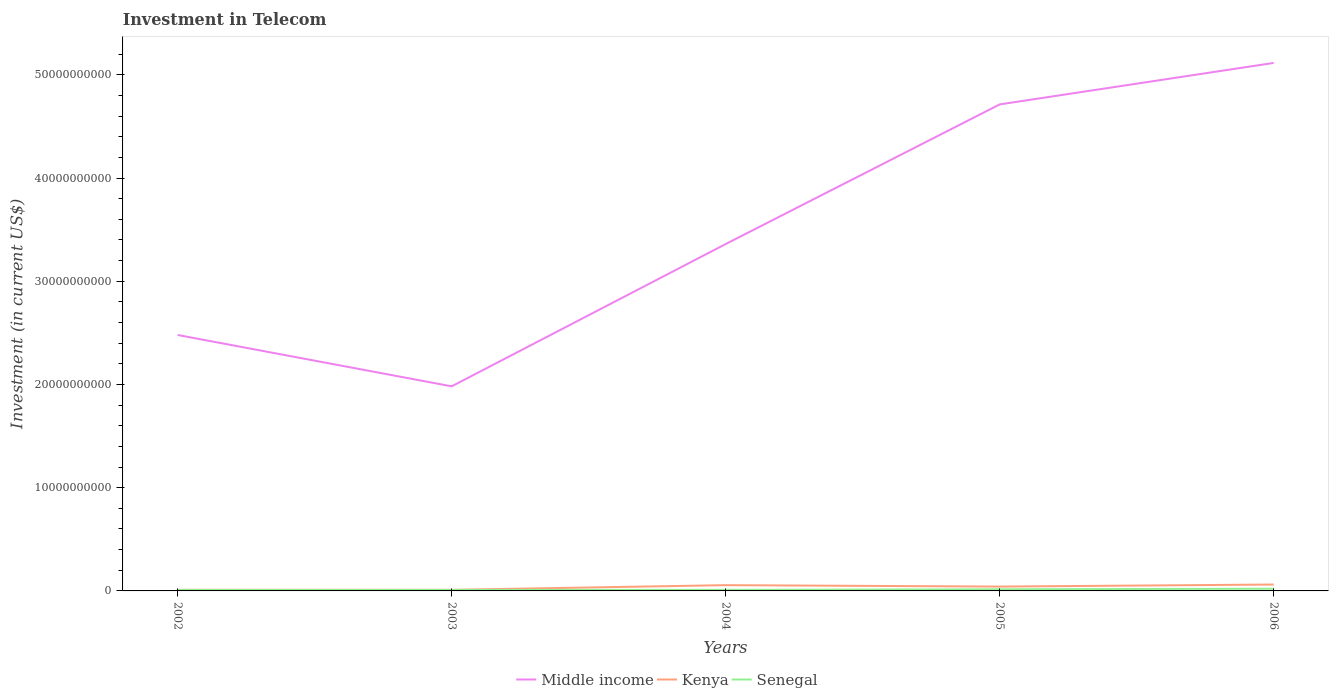Does the line corresponding to Middle income intersect with the line corresponding to Kenya?
Provide a short and direct response. No. Is the number of lines equal to the number of legend labels?
Offer a very short reply. Yes. Across all years, what is the maximum amount invested in telecom in Senegal?
Provide a short and direct response. 9.40e+07. In which year was the amount invested in telecom in Kenya maximum?
Make the answer very short. 2002. What is the total amount invested in telecom in Middle income in the graph?
Provide a short and direct response. -3.13e+1. What is the difference between the highest and the second highest amount invested in telecom in Middle income?
Your answer should be very brief. 3.13e+1. Is the amount invested in telecom in Middle income strictly greater than the amount invested in telecom in Senegal over the years?
Ensure brevity in your answer.  No. How many years are there in the graph?
Provide a succinct answer. 5. Does the graph contain any zero values?
Offer a very short reply. No. Does the graph contain grids?
Your response must be concise. No. Where does the legend appear in the graph?
Ensure brevity in your answer.  Bottom center. What is the title of the graph?
Make the answer very short. Investment in Telecom. Does "Brazil" appear as one of the legend labels in the graph?
Give a very brief answer. No. What is the label or title of the X-axis?
Keep it short and to the point. Years. What is the label or title of the Y-axis?
Make the answer very short. Investment (in current US$). What is the Investment (in current US$) in Middle income in 2002?
Give a very brief answer. 2.48e+1. What is the Investment (in current US$) of Kenya in 2002?
Ensure brevity in your answer.  1.08e+08. What is the Investment (in current US$) in Senegal in 2002?
Your answer should be compact. 9.40e+07. What is the Investment (in current US$) of Middle income in 2003?
Provide a succinct answer. 1.98e+1. What is the Investment (in current US$) of Kenya in 2003?
Offer a terse response. 1.08e+08. What is the Investment (in current US$) of Senegal in 2003?
Provide a succinct answer. 9.53e+07. What is the Investment (in current US$) in Middle income in 2004?
Provide a short and direct response. 3.36e+1. What is the Investment (in current US$) of Kenya in 2004?
Keep it short and to the point. 5.59e+08. What is the Investment (in current US$) in Senegal in 2004?
Your answer should be very brief. 1.04e+08. What is the Investment (in current US$) of Middle income in 2005?
Make the answer very short. 4.71e+1. What is the Investment (in current US$) of Kenya in 2005?
Keep it short and to the point. 4.21e+08. What is the Investment (in current US$) of Senegal in 2005?
Provide a short and direct response. 1.57e+08. What is the Investment (in current US$) in Middle income in 2006?
Provide a short and direct response. 5.12e+1. What is the Investment (in current US$) of Kenya in 2006?
Offer a very short reply. 6.19e+08. What is the Investment (in current US$) in Senegal in 2006?
Your answer should be compact. 2.12e+08. Across all years, what is the maximum Investment (in current US$) in Middle income?
Give a very brief answer. 5.12e+1. Across all years, what is the maximum Investment (in current US$) in Kenya?
Ensure brevity in your answer.  6.19e+08. Across all years, what is the maximum Investment (in current US$) of Senegal?
Give a very brief answer. 2.12e+08. Across all years, what is the minimum Investment (in current US$) of Middle income?
Make the answer very short. 1.98e+1. Across all years, what is the minimum Investment (in current US$) of Kenya?
Your answer should be very brief. 1.08e+08. Across all years, what is the minimum Investment (in current US$) in Senegal?
Make the answer very short. 9.40e+07. What is the total Investment (in current US$) of Middle income in the graph?
Make the answer very short. 1.77e+11. What is the total Investment (in current US$) in Kenya in the graph?
Your answer should be compact. 1.82e+09. What is the total Investment (in current US$) in Senegal in the graph?
Your response must be concise. 6.62e+08. What is the difference between the Investment (in current US$) of Middle income in 2002 and that in 2003?
Your answer should be very brief. 4.97e+09. What is the difference between the Investment (in current US$) in Kenya in 2002 and that in 2003?
Provide a succinct answer. 0. What is the difference between the Investment (in current US$) of Senegal in 2002 and that in 2003?
Offer a terse response. -1.30e+06. What is the difference between the Investment (in current US$) of Middle income in 2002 and that in 2004?
Offer a terse response. -8.81e+09. What is the difference between the Investment (in current US$) in Kenya in 2002 and that in 2004?
Your response must be concise. -4.51e+08. What is the difference between the Investment (in current US$) of Senegal in 2002 and that in 2004?
Your answer should be compact. -1.00e+07. What is the difference between the Investment (in current US$) of Middle income in 2002 and that in 2005?
Offer a very short reply. -2.23e+1. What is the difference between the Investment (in current US$) of Kenya in 2002 and that in 2005?
Your answer should be compact. -3.13e+08. What is the difference between the Investment (in current US$) in Senegal in 2002 and that in 2005?
Offer a terse response. -6.30e+07. What is the difference between the Investment (in current US$) in Middle income in 2002 and that in 2006?
Your response must be concise. -2.64e+1. What is the difference between the Investment (in current US$) of Kenya in 2002 and that in 2006?
Provide a succinct answer. -5.11e+08. What is the difference between the Investment (in current US$) of Senegal in 2002 and that in 2006?
Keep it short and to the point. -1.18e+08. What is the difference between the Investment (in current US$) in Middle income in 2003 and that in 2004?
Make the answer very short. -1.38e+1. What is the difference between the Investment (in current US$) of Kenya in 2003 and that in 2004?
Your answer should be compact. -4.51e+08. What is the difference between the Investment (in current US$) of Senegal in 2003 and that in 2004?
Provide a short and direct response. -8.70e+06. What is the difference between the Investment (in current US$) in Middle income in 2003 and that in 2005?
Your answer should be very brief. -2.73e+1. What is the difference between the Investment (in current US$) of Kenya in 2003 and that in 2005?
Offer a terse response. -3.13e+08. What is the difference between the Investment (in current US$) of Senegal in 2003 and that in 2005?
Offer a very short reply. -6.17e+07. What is the difference between the Investment (in current US$) of Middle income in 2003 and that in 2006?
Your answer should be very brief. -3.13e+1. What is the difference between the Investment (in current US$) of Kenya in 2003 and that in 2006?
Keep it short and to the point. -5.11e+08. What is the difference between the Investment (in current US$) in Senegal in 2003 and that in 2006?
Offer a very short reply. -1.17e+08. What is the difference between the Investment (in current US$) in Middle income in 2004 and that in 2005?
Provide a short and direct response. -1.35e+1. What is the difference between the Investment (in current US$) in Kenya in 2004 and that in 2005?
Ensure brevity in your answer.  1.38e+08. What is the difference between the Investment (in current US$) of Senegal in 2004 and that in 2005?
Offer a very short reply. -5.30e+07. What is the difference between the Investment (in current US$) in Middle income in 2004 and that in 2006?
Make the answer very short. -1.75e+1. What is the difference between the Investment (in current US$) of Kenya in 2004 and that in 2006?
Offer a terse response. -6.00e+07. What is the difference between the Investment (in current US$) of Senegal in 2004 and that in 2006?
Provide a short and direct response. -1.08e+08. What is the difference between the Investment (in current US$) in Middle income in 2005 and that in 2006?
Your answer should be very brief. -4.02e+09. What is the difference between the Investment (in current US$) of Kenya in 2005 and that in 2006?
Your answer should be very brief. -1.98e+08. What is the difference between the Investment (in current US$) of Senegal in 2005 and that in 2006?
Provide a succinct answer. -5.50e+07. What is the difference between the Investment (in current US$) of Middle income in 2002 and the Investment (in current US$) of Kenya in 2003?
Give a very brief answer. 2.47e+1. What is the difference between the Investment (in current US$) in Middle income in 2002 and the Investment (in current US$) in Senegal in 2003?
Make the answer very short. 2.47e+1. What is the difference between the Investment (in current US$) in Kenya in 2002 and the Investment (in current US$) in Senegal in 2003?
Make the answer very short. 1.27e+07. What is the difference between the Investment (in current US$) of Middle income in 2002 and the Investment (in current US$) of Kenya in 2004?
Your answer should be very brief. 2.42e+1. What is the difference between the Investment (in current US$) in Middle income in 2002 and the Investment (in current US$) in Senegal in 2004?
Provide a short and direct response. 2.47e+1. What is the difference between the Investment (in current US$) in Middle income in 2002 and the Investment (in current US$) in Kenya in 2005?
Provide a short and direct response. 2.44e+1. What is the difference between the Investment (in current US$) in Middle income in 2002 and the Investment (in current US$) in Senegal in 2005?
Your response must be concise. 2.46e+1. What is the difference between the Investment (in current US$) in Kenya in 2002 and the Investment (in current US$) in Senegal in 2005?
Your answer should be compact. -4.90e+07. What is the difference between the Investment (in current US$) of Middle income in 2002 and the Investment (in current US$) of Kenya in 2006?
Keep it short and to the point. 2.42e+1. What is the difference between the Investment (in current US$) of Middle income in 2002 and the Investment (in current US$) of Senegal in 2006?
Your answer should be very brief. 2.46e+1. What is the difference between the Investment (in current US$) of Kenya in 2002 and the Investment (in current US$) of Senegal in 2006?
Your answer should be very brief. -1.04e+08. What is the difference between the Investment (in current US$) in Middle income in 2003 and the Investment (in current US$) in Kenya in 2004?
Make the answer very short. 1.93e+1. What is the difference between the Investment (in current US$) in Middle income in 2003 and the Investment (in current US$) in Senegal in 2004?
Offer a terse response. 1.97e+1. What is the difference between the Investment (in current US$) of Kenya in 2003 and the Investment (in current US$) of Senegal in 2004?
Provide a short and direct response. 4.00e+06. What is the difference between the Investment (in current US$) in Middle income in 2003 and the Investment (in current US$) in Kenya in 2005?
Your answer should be compact. 1.94e+1. What is the difference between the Investment (in current US$) of Middle income in 2003 and the Investment (in current US$) of Senegal in 2005?
Provide a succinct answer. 1.97e+1. What is the difference between the Investment (in current US$) of Kenya in 2003 and the Investment (in current US$) of Senegal in 2005?
Keep it short and to the point. -4.90e+07. What is the difference between the Investment (in current US$) of Middle income in 2003 and the Investment (in current US$) of Kenya in 2006?
Ensure brevity in your answer.  1.92e+1. What is the difference between the Investment (in current US$) of Middle income in 2003 and the Investment (in current US$) of Senegal in 2006?
Offer a terse response. 1.96e+1. What is the difference between the Investment (in current US$) in Kenya in 2003 and the Investment (in current US$) in Senegal in 2006?
Ensure brevity in your answer.  -1.04e+08. What is the difference between the Investment (in current US$) of Middle income in 2004 and the Investment (in current US$) of Kenya in 2005?
Provide a short and direct response. 3.32e+1. What is the difference between the Investment (in current US$) of Middle income in 2004 and the Investment (in current US$) of Senegal in 2005?
Your answer should be very brief. 3.34e+1. What is the difference between the Investment (in current US$) in Kenya in 2004 and the Investment (in current US$) in Senegal in 2005?
Provide a succinct answer. 4.02e+08. What is the difference between the Investment (in current US$) of Middle income in 2004 and the Investment (in current US$) of Kenya in 2006?
Provide a short and direct response. 3.30e+1. What is the difference between the Investment (in current US$) of Middle income in 2004 and the Investment (in current US$) of Senegal in 2006?
Provide a short and direct response. 3.34e+1. What is the difference between the Investment (in current US$) in Kenya in 2004 and the Investment (in current US$) in Senegal in 2006?
Keep it short and to the point. 3.47e+08. What is the difference between the Investment (in current US$) in Middle income in 2005 and the Investment (in current US$) in Kenya in 2006?
Your response must be concise. 4.65e+1. What is the difference between the Investment (in current US$) in Middle income in 2005 and the Investment (in current US$) in Senegal in 2006?
Keep it short and to the point. 4.69e+1. What is the difference between the Investment (in current US$) in Kenya in 2005 and the Investment (in current US$) in Senegal in 2006?
Offer a very short reply. 2.09e+08. What is the average Investment (in current US$) in Middle income per year?
Your response must be concise. 3.53e+1. What is the average Investment (in current US$) in Kenya per year?
Your response must be concise. 3.63e+08. What is the average Investment (in current US$) in Senegal per year?
Provide a succinct answer. 1.32e+08. In the year 2002, what is the difference between the Investment (in current US$) of Middle income and Investment (in current US$) of Kenya?
Provide a succinct answer. 2.47e+1. In the year 2002, what is the difference between the Investment (in current US$) of Middle income and Investment (in current US$) of Senegal?
Offer a terse response. 2.47e+1. In the year 2002, what is the difference between the Investment (in current US$) in Kenya and Investment (in current US$) in Senegal?
Give a very brief answer. 1.40e+07. In the year 2003, what is the difference between the Investment (in current US$) of Middle income and Investment (in current US$) of Kenya?
Offer a terse response. 1.97e+1. In the year 2003, what is the difference between the Investment (in current US$) in Middle income and Investment (in current US$) in Senegal?
Your response must be concise. 1.97e+1. In the year 2003, what is the difference between the Investment (in current US$) in Kenya and Investment (in current US$) in Senegal?
Your response must be concise. 1.27e+07. In the year 2004, what is the difference between the Investment (in current US$) in Middle income and Investment (in current US$) in Kenya?
Your response must be concise. 3.30e+1. In the year 2004, what is the difference between the Investment (in current US$) in Middle income and Investment (in current US$) in Senegal?
Provide a succinct answer. 3.35e+1. In the year 2004, what is the difference between the Investment (in current US$) of Kenya and Investment (in current US$) of Senegal?
Offer a terse response. 4.55e+08. In the year 2005, what is the difference between the Investment (in current US$) of Middle income and Investment (in current US$) of Kenya?
Your answer should be very brief. 4.67e+1. In the year 2005, what is the difference between the Investment (in current US$) in Middle income and Investment (in current US$) in Senegal?
Offer a terse response. 4.70e+1. In the year 2005, what is the difference between the Investment (in current US$) in Kenya and Investment (in current US$) in Senegal?
Your answer should be very brief. 2.64e+08. In the year 2006, what is the difference between the Investment (in current US$) in Middle income and Investment (in current US$) in Kenya?
Make the answer very short. 5.05e+1. In the year 2006, what is the difference between the Investment (in current US$) of Middle income and Investment (in current US$) of Senegal?
Give a very brief answer. 5.09e+1. In the year 2006, what is the difference between the Investment (in current US$) of Kenya and Investment (in current US$) of Senegal?
Keep it short and to the point. 4.07e+08. What is the ratio of the Investment (in current US$) of Middle income in 2002 to that in 2003?
Your response must be concise. 1.25. What is the ratio of the Investment (in current US$) in Kenya in 2002 to that in 2003?
Your answer should be very brief. 1. What is the ratio of the Investment (in current US$) in Senegal in 2002 to that in 2003?
Make the answer very short. 0.99. What is the ratio of the Investment (in current US$) of Middle income in 2002 to that in 2004?
Give a very brief answer. 0.74. What is the ratio of the Investment (in current US$) in Kenya in 2002 to that in 2004?
Offer a very short reply. 0.19. What is the ratio of the Investment (in current US$) in Senegal in 2002 to that in 2004?
Provide a short and direct response. 0.9. What is the ratio of the Investment (in current US$) of Middle income in 2002 to that in 2005?
Your answer should be very brief. 0.53. What is the ratio of the Investment (in current US$) of Kenya in 2002 to that in 2005?
Provide a succinct answer. 0.26. What is the ratio of the Investment (in current US$) of Senegal in 2002 to that in 2005?
Provide a short and direct response. 0.6. What is the ratio of the Investment (in current US$) in Middle income in 2002 to that in 2006?
Ensure brevity in your answer.  0.48. What is the ratio of the Investment (in current US$) in Kenya in 2002 to that in 2006?
Give a very brief answer. 0.17. What is the ratio of the Investment (in current US$) of Senegal in 2002 to that in 2006?
Offer a very short reply. 0.44. What is the ratio of the Investment (in current US$) in Middle income in 2003 to that in 2004?
Your answer should be compact. 0.59. What is the ratio of the Investment (in current US$) in Kenya in 2003 to that in 2004?
Keep it short and to the point. 0.19. What is the ratio of the Investment (in current US$) of Senegal in 2003 to that in 2004?
Provide a short and direct response. 0.92. What is the ratio of the Investment (in current US$) of Middle income in 2003 to that in 2005?
Provide a short and direct response. 0.42. What is the ratio of the Investment (in current US$) of Kenya in 2003 to that in 2005?
Offer a terse response. 0.26. What is the ratio of the Investment (in current US$) in Senegal in 2003 to that in 2005?
Keep it short and to the point. 0.61. What is the ratio of the Investment (in current US$) in Middle income in 2003 to that in 2006?
Offer a very short reply. 0.39. What is the ratio of the Investment (in current US$) of Kenya in 2003 to that in 2006?
Keep it short and to the point. 0.17. What is the ratio of the Investment (in current US$) of Senegal in 2003 to that in 2006?
Make the answer very short. 0.45. What is the ratio of the Investment (in current US$) of Middle income in 2004 to that in 2005?
Give a very brief answer. 0.71. What is the ratio of the Investment (in current US$) of Kenya in 2004 to that in 2005?
Make the answer very short. 1.33. What is the ratio of the Investment (in current US$) in Senegal in 2004 to that in 2005?
Offer a terse response. 0.66. What is the ratio of the Investment (in current US$) in Middle income in 2004 to that in 2006?
Ensure brevity in your answer.  0.66. What is the ratio of the Investment (in current US$) in Kenya in 2004 to that in 2006?
Your response must be concise. 0.9. What is the ratio of the Investment (in current US$) in Senegal in 2004 to that in 2006?
Offer a very short reply. 0.49. What is the ratio of the Investment (in current US$) in Middle income in 2005 to that in 2006?
Your response must be concise. 0.92. What is the ratio of the Investment (in current US$) of Kenya in 2005 to that in 2006?
Your answer should be very brief. 0.68. What is the ratio of the Investment (in current US$) in Senegal in 2005 to that in 2006?
Your response must be concise. 0.74. What is the difference between the highest and the second highest Investment (in current US$) of Middle income?
Provide a succinct answer. 4.02e+09. What is the difference between the highest and the second highest Investment (in current US$) in Kenya?
Your answer should be compact. 6.00e+07. What is the difference between the highest and the second highest Investment (in current US$) in Senegal?
Ensure brevity in your answer.  5.50e+07. What is the difference between the highest and the lowest Investment (in current US$) of Middle income?
Your answer should be compact. 3.13e+1. What is the difference between the highest and the lowest Investment (in current US$) of Kenya?
Keep it short and to the point. 5.11e+08. What is the difference between the highest and the lowest Investment (in current US$) of Senegal?
Keep it short and to the point. 1.18e+08. 